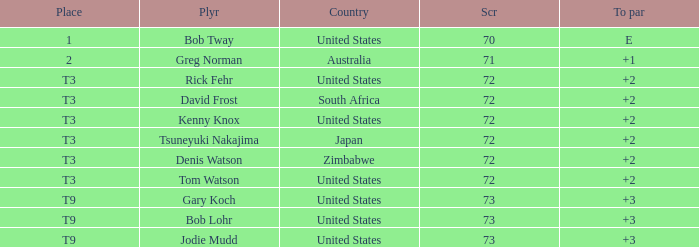Who scored more than 72? Gary Koch, Bob Lohr, Jodie Mudd. 